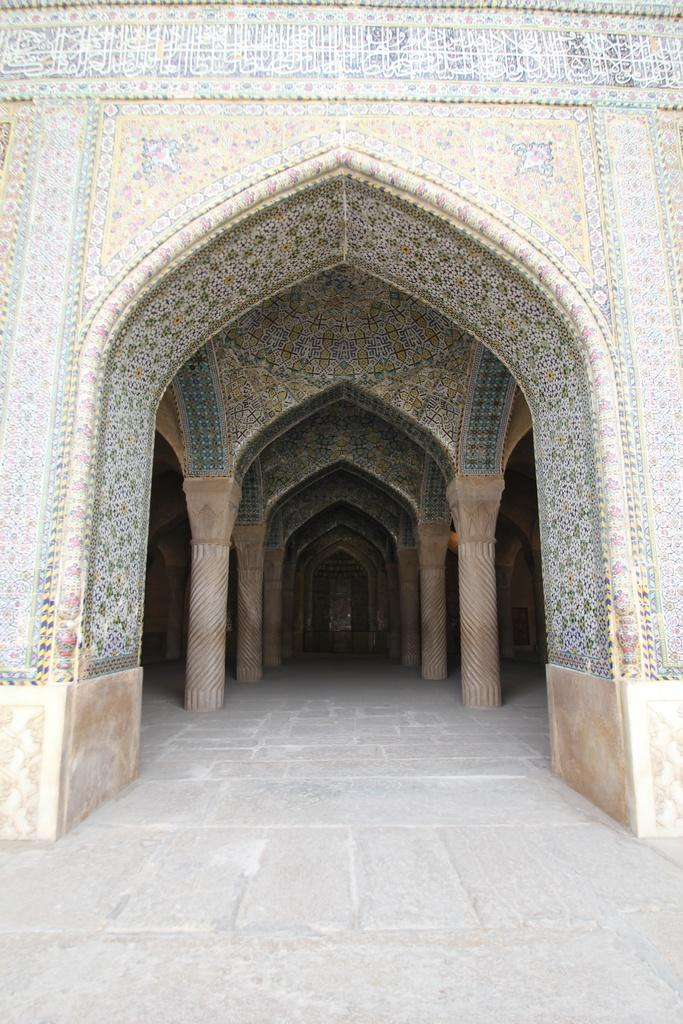What is the main subject of the image? The image depicts the entrance of a building. What material is used for the pillars at the entrance? The entrance is made of pillars. What is the building's walls made of? The walls of the building are made of stone. What type of songs can be heard coming from the building in the image? There is no indication in the image that any songs are being played or heard from the building. 